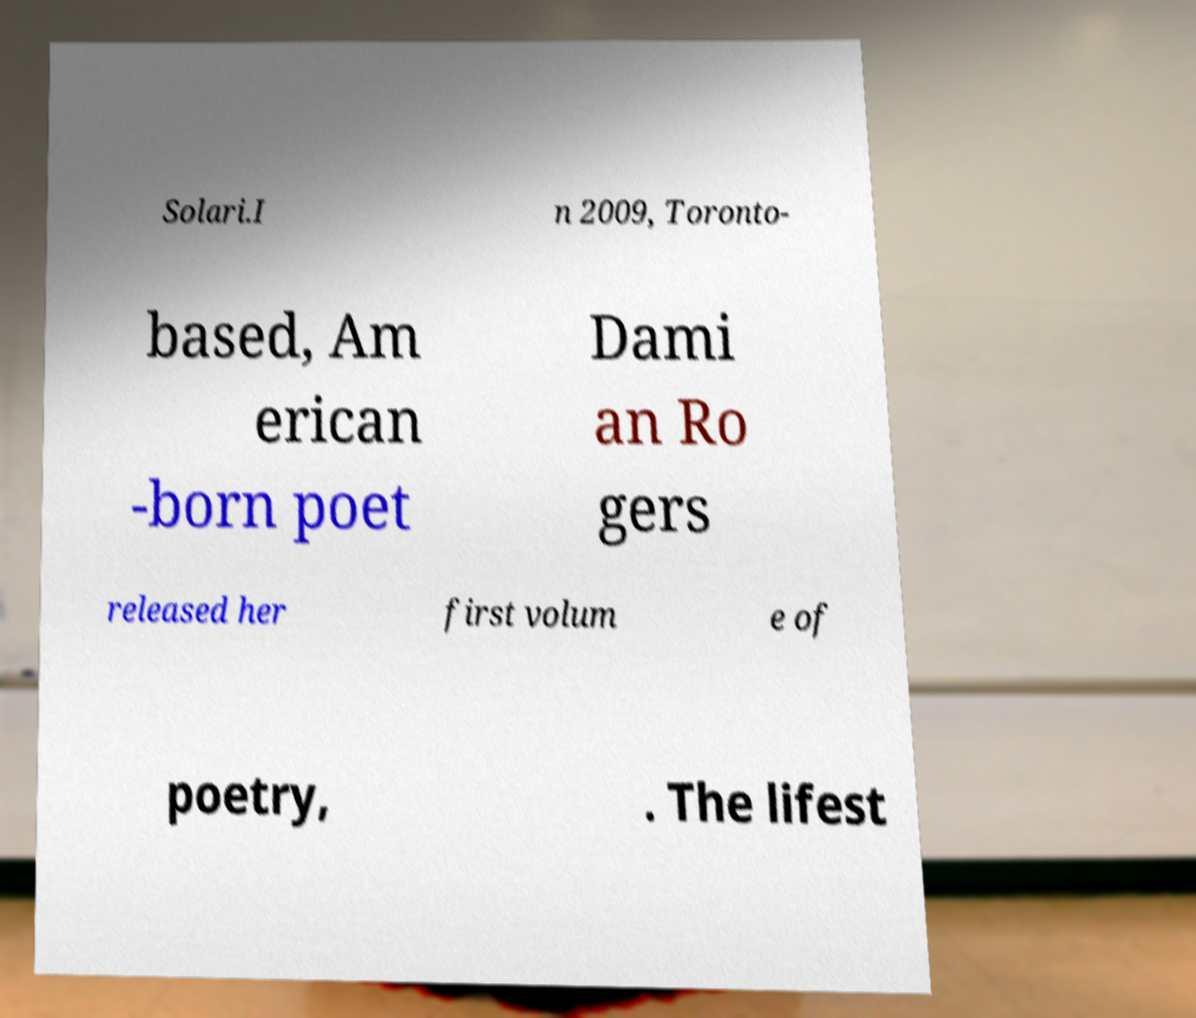Please identify and transcribe the text found in this image. Solari.I n 2009, Toronto- based, Am erican -born poet Dami an Ro gers released her first volum e of poetry, . The lifest 